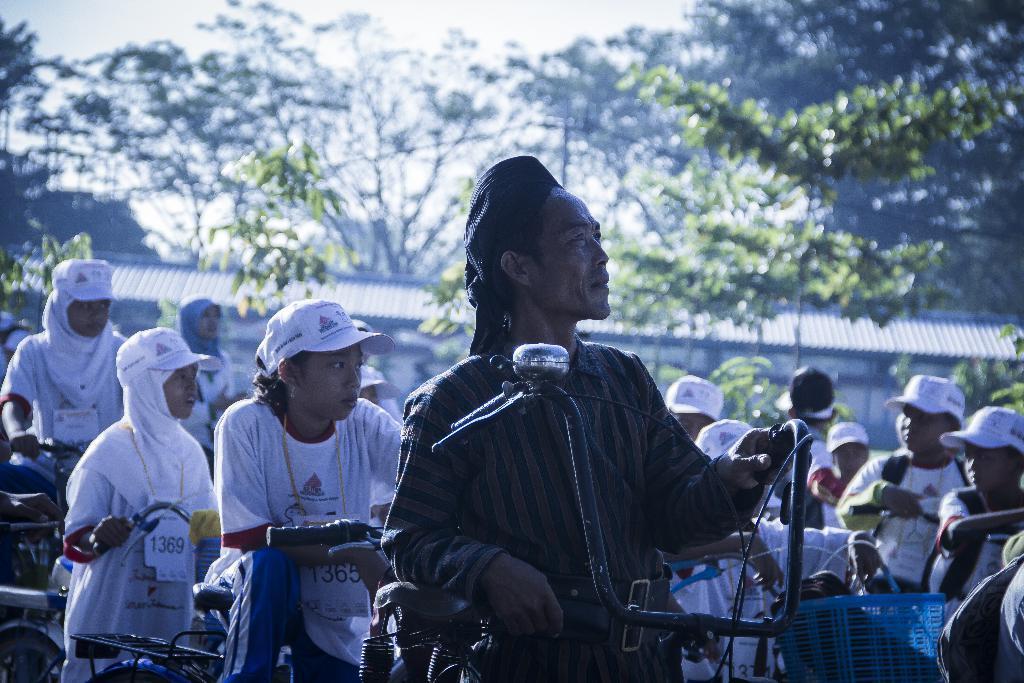Describe this image in one or two sentences. In this image, we can see some people and there are some bicycles, there are some trees. 